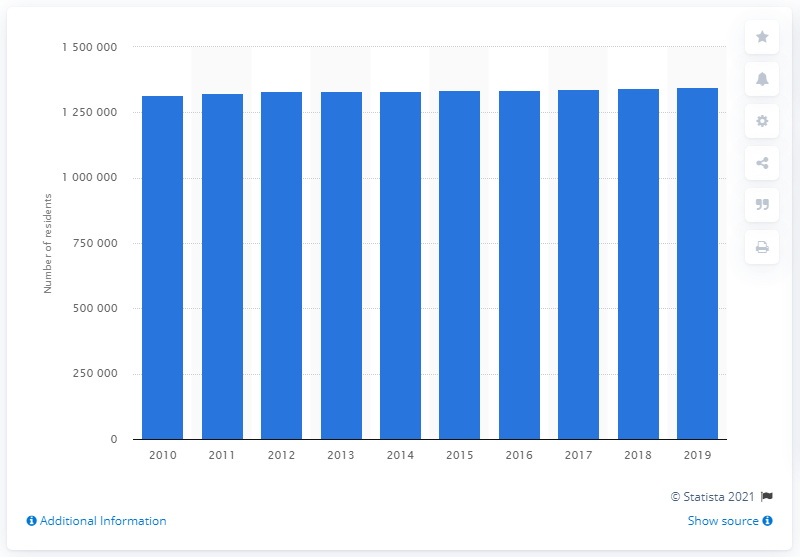List a handful of essential elements in this visual. In 2019, the Memphis metropolitan area had a population of 1,338,582 people. 